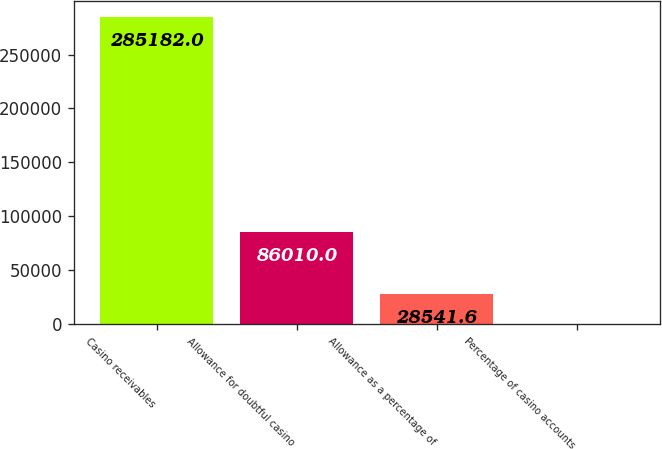Convert chart. <chart><loc_0><loc_0><loc_500><loc_500><bar_chart><fcel>Casino receivables<fcel>Allowance for doubtful casino<fcel>Allowance as a percentage of<fcel>Percentage of casino accounts<nl><fcel>285182<fcel>86010<fcel>28541.6<fcel>26<nl></chart> 